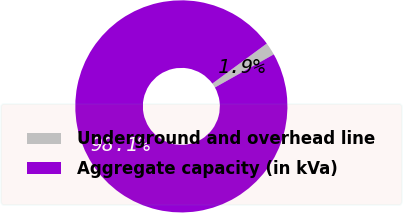Convert chart to OTSL. <chart><loc_0><loc_0><loc_500><loc_500><pie_chart><fcel>Underground and overhead line<fcel>Aggregate capacity (in kVa)<nl><fcel>1.94%<fcel>98.06%<nl></chart> 